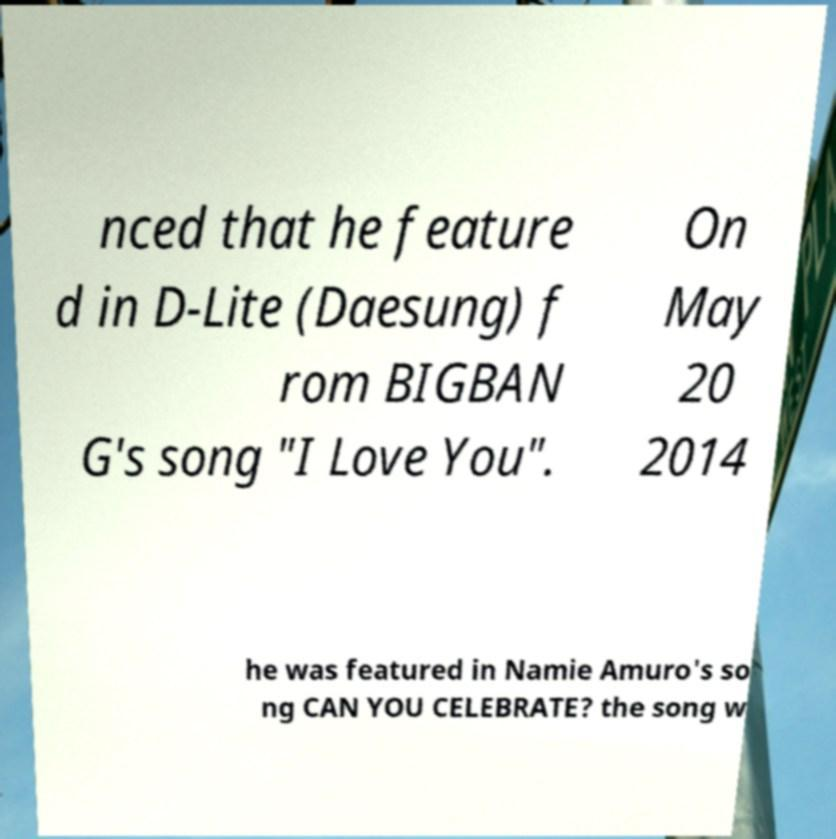Please identify and transcribe the text found in this image. nced that he feature d in D-Lite (Daesung) f rom BIGBAN G's song "I Love You". On May 20 2014 he was featured in Namie Amuro's so ng CAN YOU CELEBRATE? the song w 